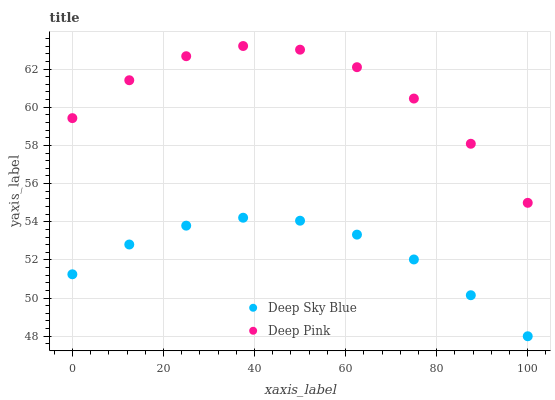Does Deep Sky Blue have the minimum area under the curve?
Answer yes or no. Yes. Does Deep Pink have the maximum area under the curve?
Answer yes or no. Yes. Does Deep Sky Blue have the maximum area under the curve?
Answer yes or no. No. Is Deep Sky Blue the smoothest?
Answer yes or no. Yes. Is Deep Pink the roughest?
Answer yes or no. Yes. Is Deep Sky Blue the roughest?
Answer yes or no. No. Does Deep Sky Blue have the lowest value?
Answer yes or no. Yes. Does Deep Pink have the highest value?
Answer yes or no. Yes. Does Deep Sky Blue have the highest value?
Answer yes or no. No. Is Deep Sky Blue less than Deep Pink?
Answer yes or no. Yes. Is Deep Pink greater than Deep Sky Blue?
Answer yes or no. Yes. Does Deep Sky Blue intersect Deep Pink?
Answer yes or no. No. 